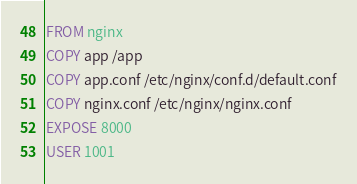<code> <loc_0><loc_0><loc_500><loc_500><_Dockerfile_>FROM nginx
COPY app /app
COPY app.conf /etc/nginx/conf.d/default.conf
COPY nginx.conf /etc/nginx/nginx.conf
EXPOSE 8000
USER 1001
</code> 